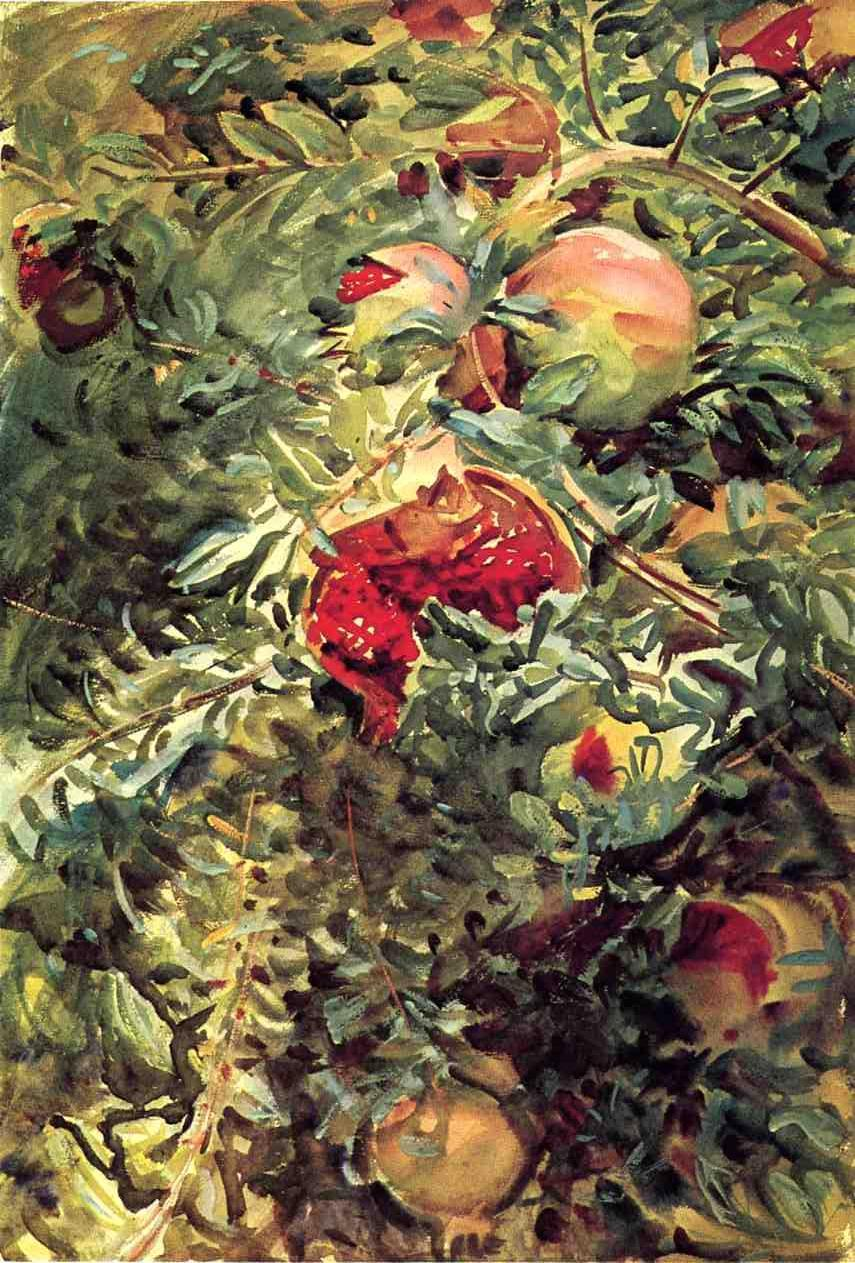Could the choice of fruits have any symbolic meaning in this painting? Yes, the depiction of fruits such as apples and strawberries could be symbolic. Apples often represent knowledge, fertility, and abundance in various cultural contexts, while strawberries might symbolize purity and temptation. In this context, the painter might be using these fruits to evoke themes of fertility and the earth’s generosity or to hint at deeper meanings of knowledge and temptation intertwined with natural beauty. 